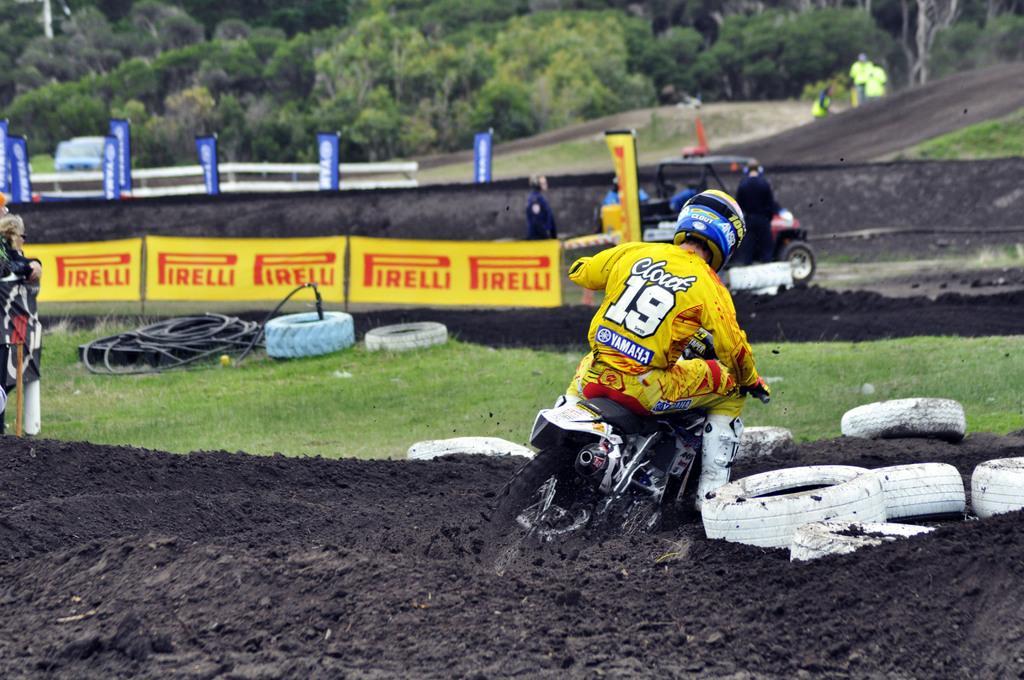Could you give a brief overview of what you see in this image? In this picture we can see a person on a motorcycle and tyres on the ground, here we can see people, vehicles, banners and some objects and in the background we can see trees. 